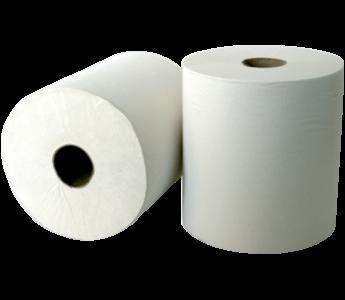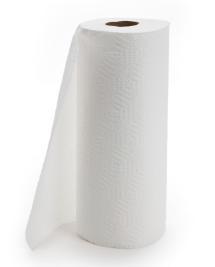The first image is the image on the left, the second image is the image on the right. Assess this claim about the two images: "An image shows exactly one roll standing next to one roll on its side.". Correct or not? Answer yes or no. Yes. The first image is the image on the left, the second image is the image on the right. Evaluate the accuracy of this statement regarding the images: "Both images show white paper towels on rolls.". Is it true? Answer yes or no. Yes. 